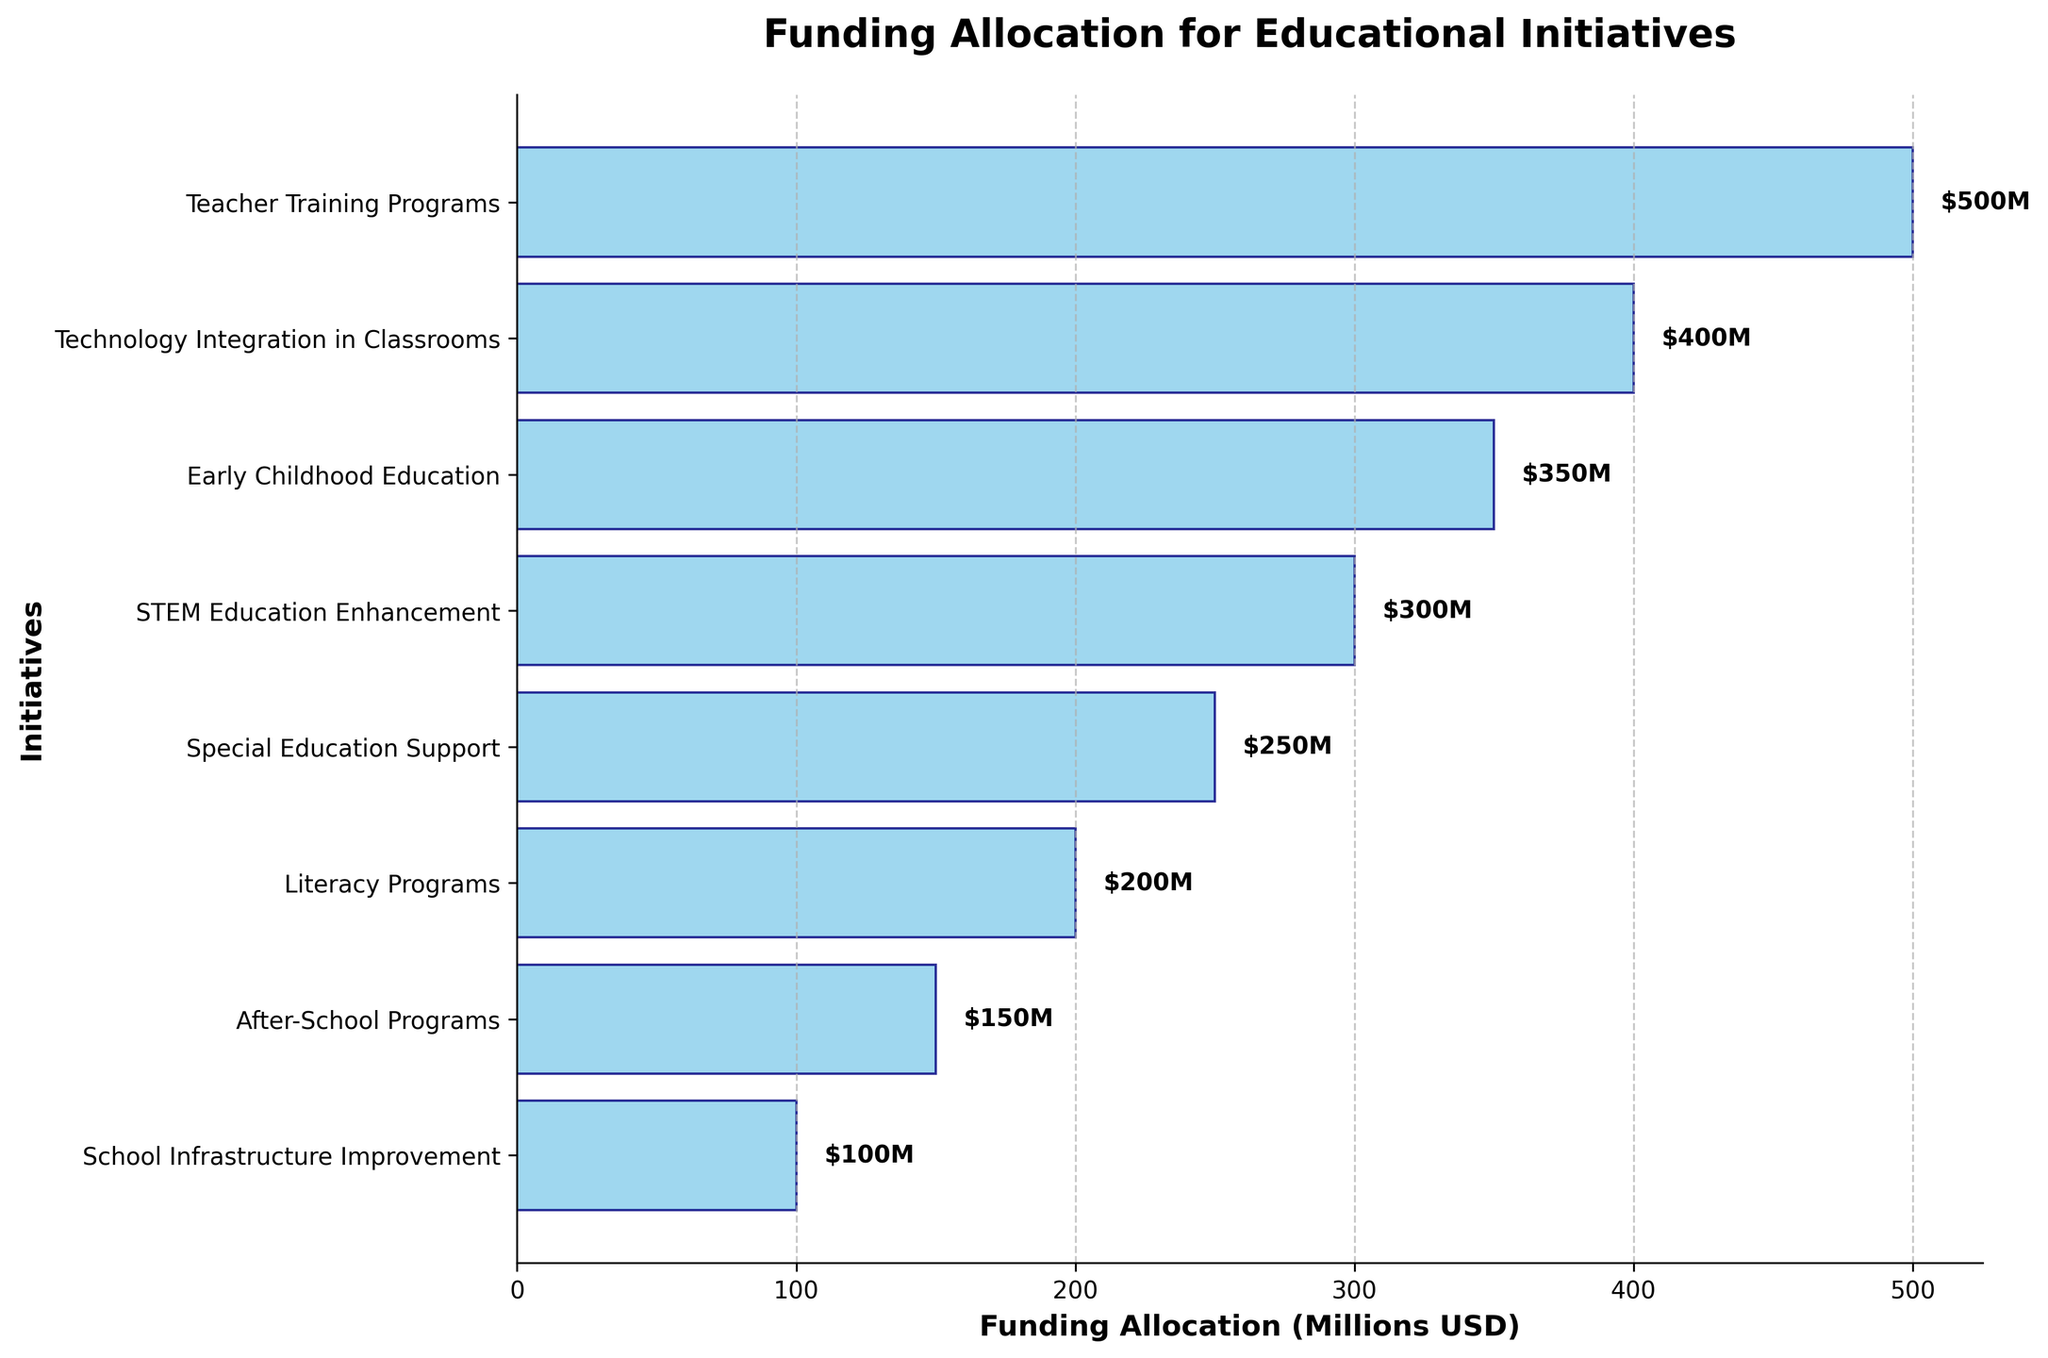Which initiative receives the highest funding allocation? The initiative with the highest funding allocation is positioned at the bottom of the funnel chart. It is "Teacher Training Programs," which receives $500 million.
Answer: Teacher Training Programs How much funding is allocated to Technology Integration in Classrooms? The plot shows that "Technology Integration in Classrooms" receives the second-highest funding allocation in the funnel, which is labeled as $400 million.
Answer: $400 million What is the total funding allocation for the top three initiatives? Summing the funding allocations for "Teacher Training Programs" ($500M), "Technology Integration in Classrooms" ($400M), and "Early Childhood Education" ($350M) results in a total of $1250 million.
Answer: $1250 million Which initiative receives the least funding allocation? The initiative with the smallest bar, located at the top of the funnel chart, is "School Infrastructure Improvement," which receives $100 million.
Answer: School Infrastructure Improvement How much more funding is allocated to STEM Education Enhancement compared to Literacy Programs? The funding for "STEM Education Enhancement" is $300 million, and for "Literacy Programs" it is $200 million. The difference in funding is $300M - $200M = $100 million.
Answer: $100 million What is the average funding allocation for all initiatives? Summing up all funding values: $500M + $400M + $350M + $300M + $250M + $200M + $150M + $100M = $2250 million. There are 8 initiatives, so the average is $2250M / 8 = $281.25 million.
Answer: $281.25 million Are there more initiatives with funding allocations above or below $250 million? Initiatives with above $250 million: Teacher Training Programs, Technology Integration in Classrooms, Early Childhood Education. Initiatives with below $250 million: Special Education Support, Literacy Programs, After-School Programs, School Infrastructure Improvement. Both sides have the same count: 3 above and 4 below.
Answer: More below Which initiatives have funding allocations equal to or greater than $300 million? The initiatives that have allocations of $300 million or more are "Teacher Training Programs" ($500M), "Technology Integration in Classrooms" ($400M), "Early Childhood Education" ($350M), and "STEM Education Enhancement" ($300M).
Answer: Teacher Training Programs, Technology Integration in Classrooms, Early Childhood Education, STEM Education Enhancement If we combine the funding allocations for Special Education Support and After-School Programs, how does it compare to the funding allocation for Early Childhood Education? Special Education Support ($250M) + After-School Programs ($150M) = $400 million. This is greater than Early Childhood Education's allocation of $350 million.
Answer: Greater 